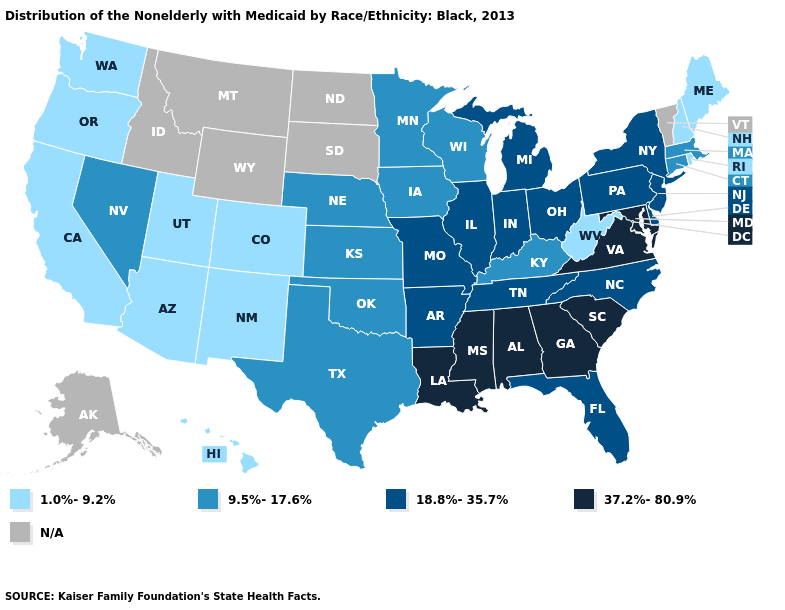Does the map have missing data?
Give a very brief answer. Yes. Does Nebraska have the lowest value in the MidWest?
Write a very short answer. Yes. Does Iowa have the highest value in the USA?
Concise answer only. No. Does Alabama have the highest value in the USA?
Be succinct. Yes. Among the states that border North Carolina , which have the highest value?
Write a very short answer. Georgia, South Carolina, Virginia. What is the lowest value in states that border Washington?
Answer briefly. 1.0%-9.2%. How many symbols are there in the legend?
Keep it brief. 5. Does the first symbol in the legend represent the smallest category?
Write a very short answer. Yes. Which states have the lowest value in the Northeast?
Keep it brief. Maine, New Hampshire, Rhode Island. Name the states that have a value in the range N/A?
Short answer required. Alaska, Idaho, Montana, North Dakota, South Dakota, Vermont, Wyoming. What is the value of Florida?
Short answer required. 18.8%-35.7%. What is the lowest value in the USA?
Short answer required. 1.0%-9.2%. What is the highest value in the USA?
Write a very short answer. 37.2%-80.9%. Which states have the highest value in the USA?
Concise answer only. Alabama, Georgia, Louisiana, Maryland, Mississippi, South Carolina, Virginia. 